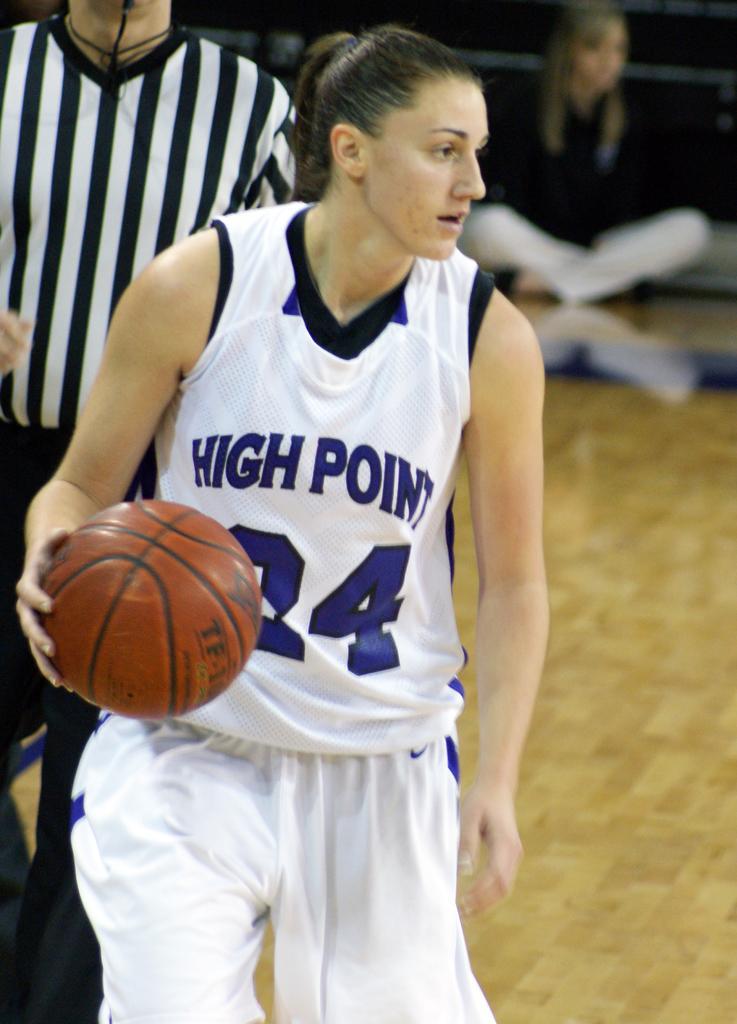How would you summarize this image in a sentence or two? In this picture there is a woman in the center holding a ball and is in the action of playing. In the background there is a person and on the right side in the background there is a woman sitting on the floor. 